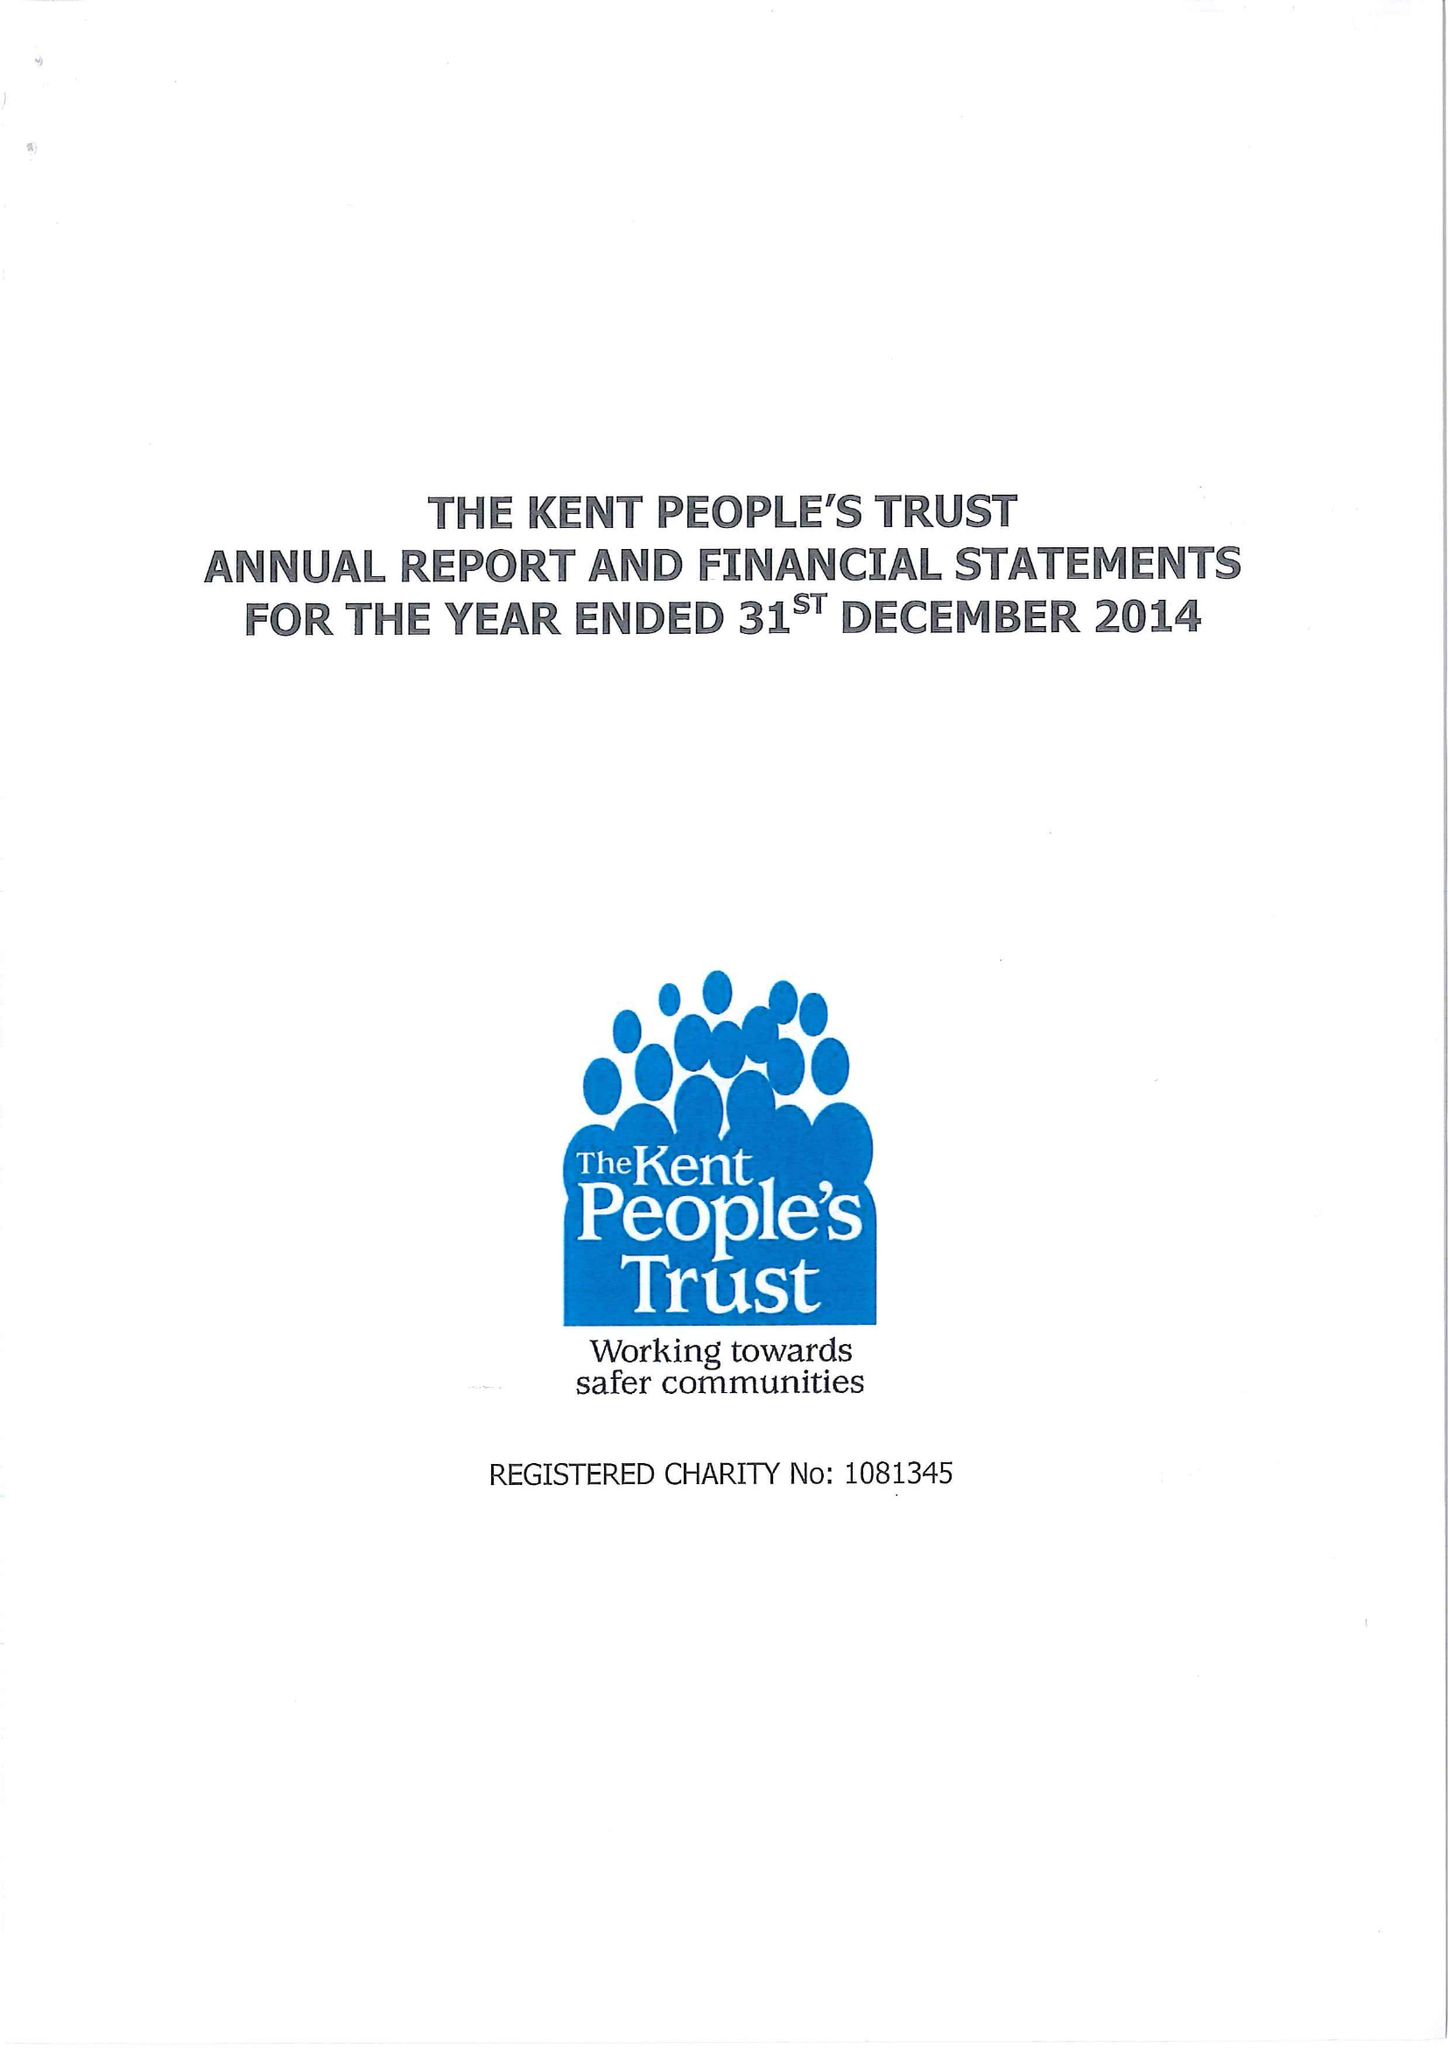What is the value for the income_annually_in_british_pounds?
Answer the question using a single word or phrase. 65792.00 